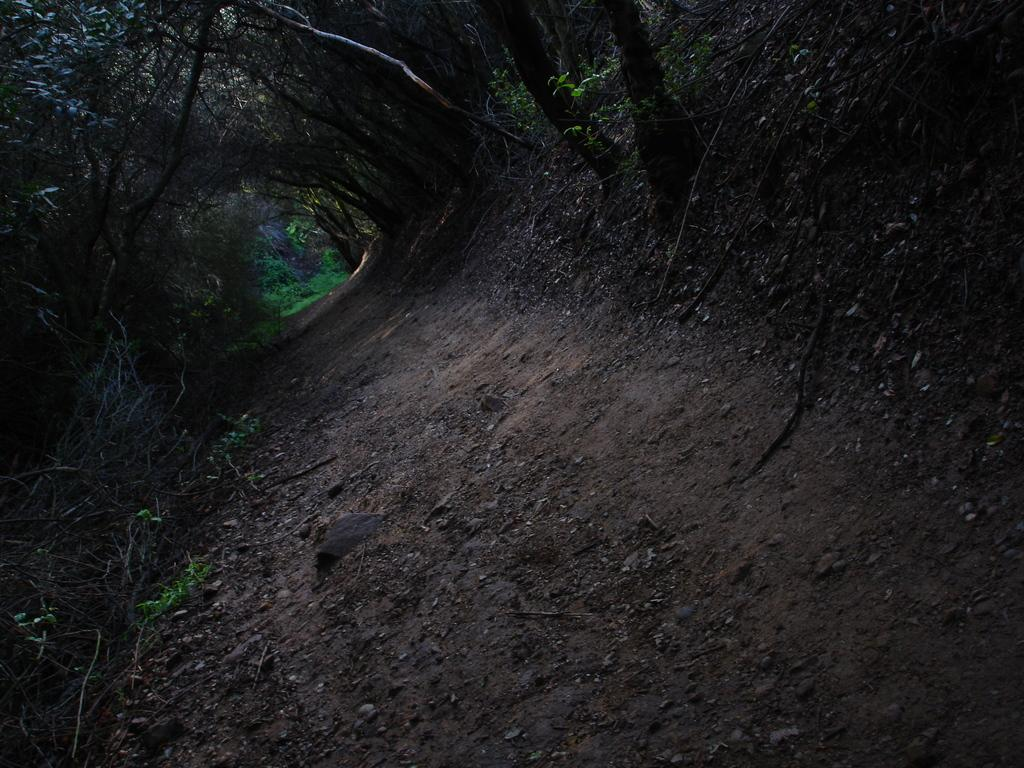What type of vegetation can be seen in the image? There are trees in the image. What is located at the bottom of the image? There is a road at the bottom of the image. What part of the tree is exchanging oxygen for carbon dioxide in the image? The provided facts do not mention any specific part of the tree or any exchange of gases, so we cannot answer this question based on the information given. 